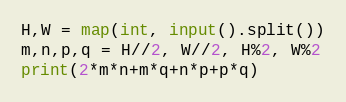<code> <loc_0><loc_0><loc_500><loc_500><_Python_>H,W = map(int, input().split())
m,n,p,q = H//2, W//2, H%2, W%2
print(2*m*n+m*q+n*p+p*q)</code> 